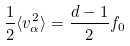Convert formula to latex. <formula><loc_0><loc_0><loc_500><loc_500>\frac { 1 } { 2 } \langle v _ { \alpha } ^ { 2 } \rangle = \frac { d - 1 } { 2 } f _ { 0 }</formula> 